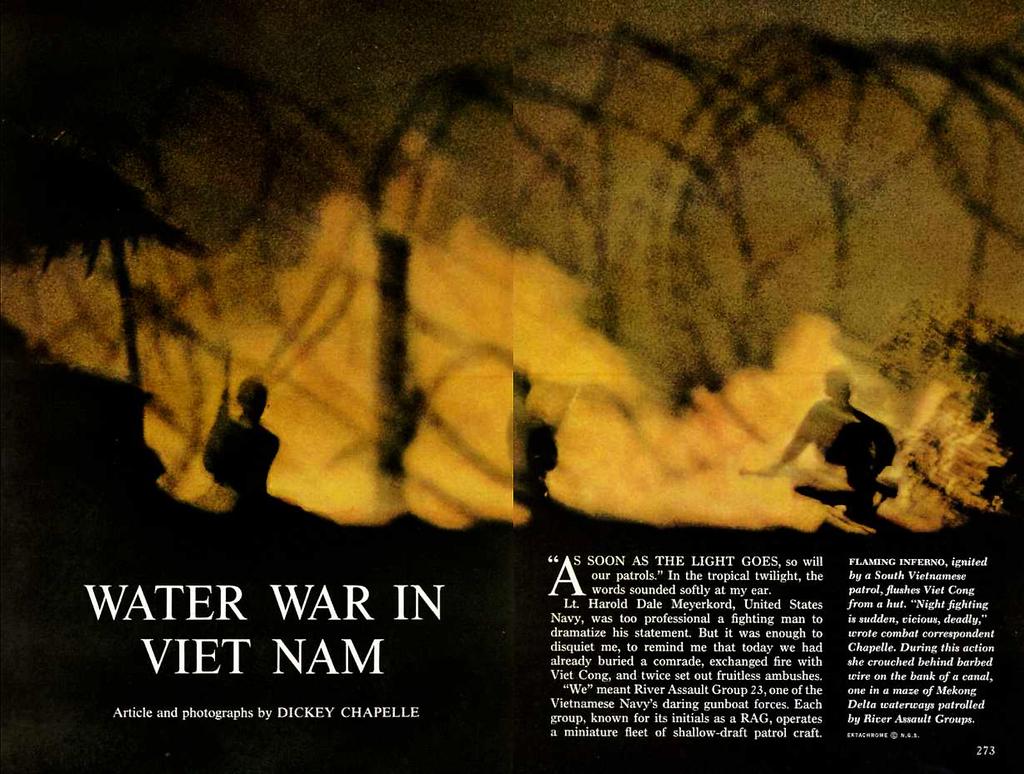What is the title of the book?
Provide a short and direct response. Water war in viet nam. Who wrote the book?
Your response must be concise. Dickey chapelle. 